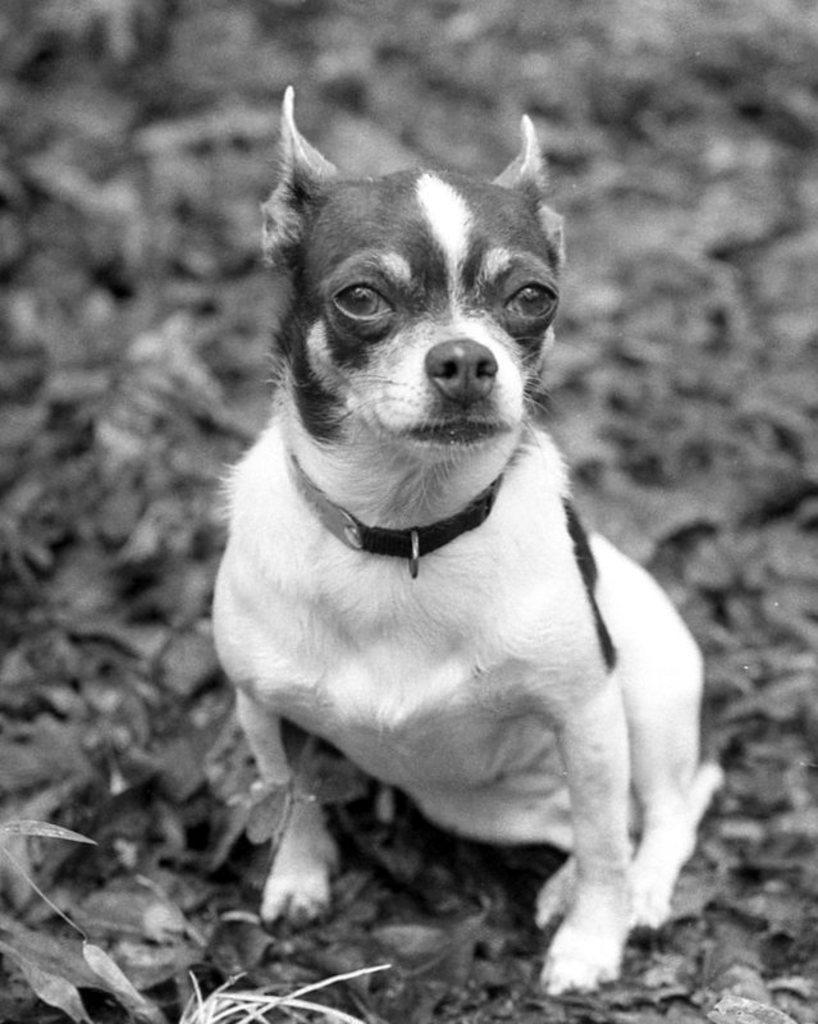What type of animal is present in the image? There is a dog in the image. Can you describe the color of the dog? The dog is white in color. How much wealth does the dog possess in the image? There is no indication of wealth in the image, as it features a dog. What time of day is depicted in the image? The image does not show any specific time of day, so it cannot be determined from the picture. 